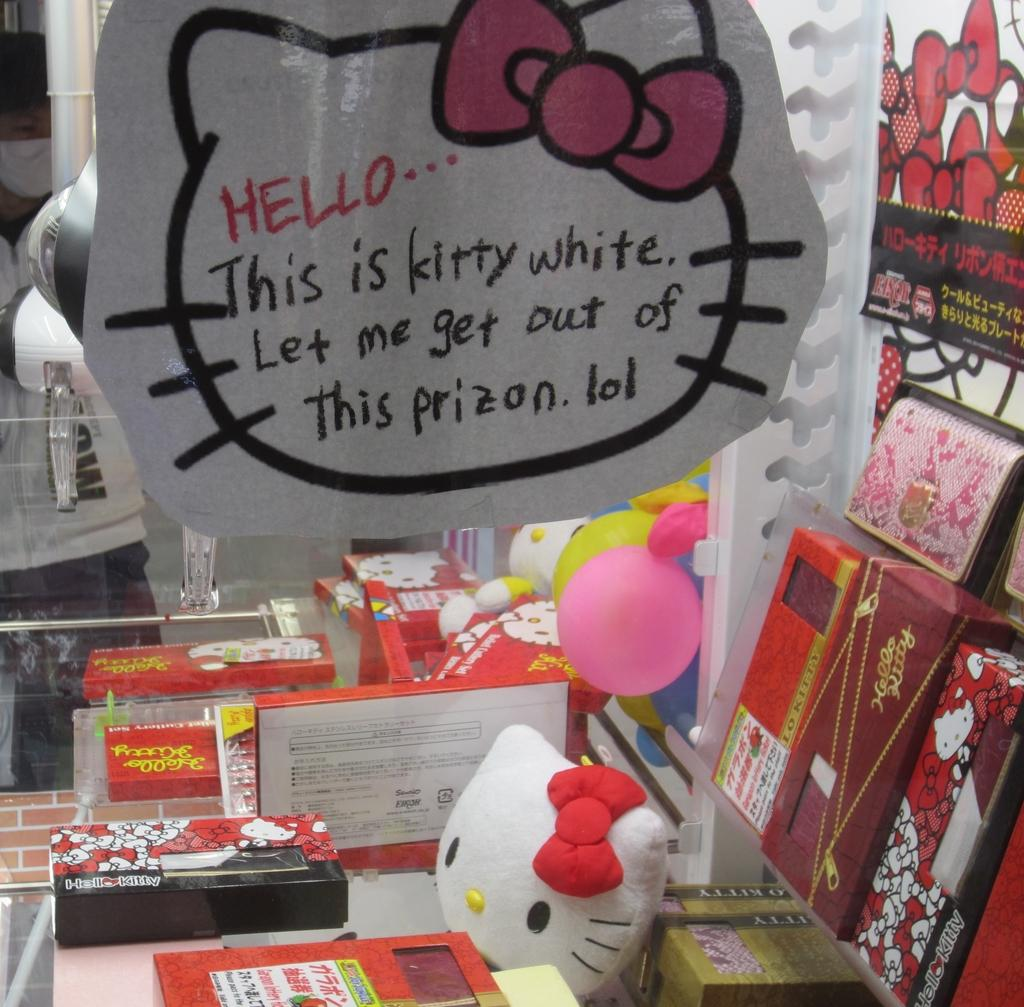<image>
Present a compact description of the photo's key features. A variety of Hello Kitty products cover a small display area. 